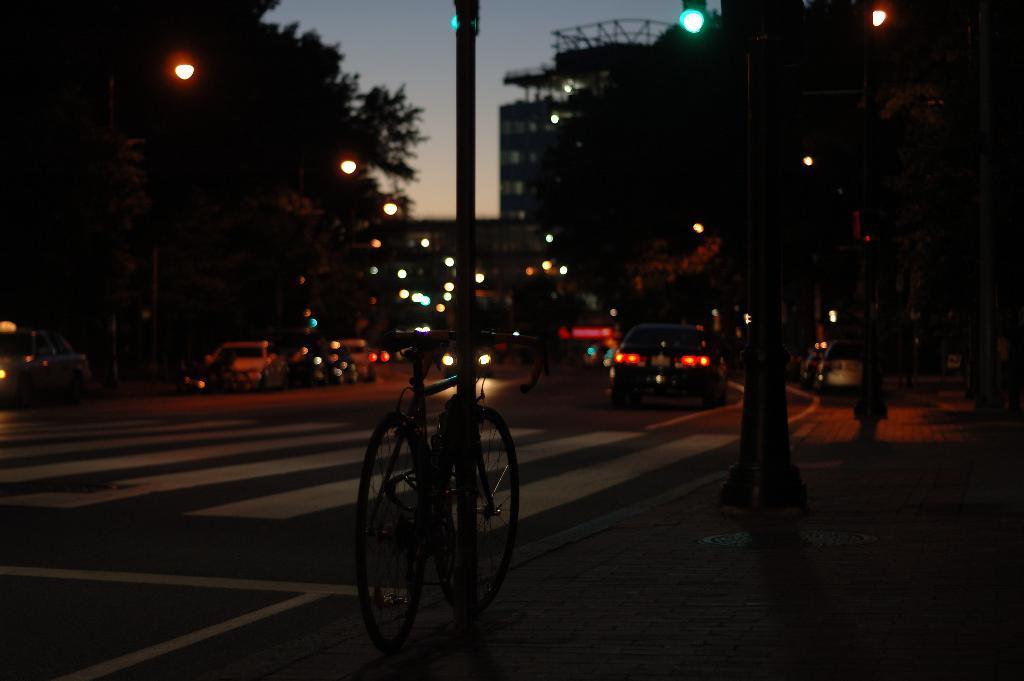Can you describe this image briefly? In the center of the image we can see one pole and one cycle. And we can see a few vehicles on the road. In the background, we can see the sky, trees, buildings, poles, lights etc. 